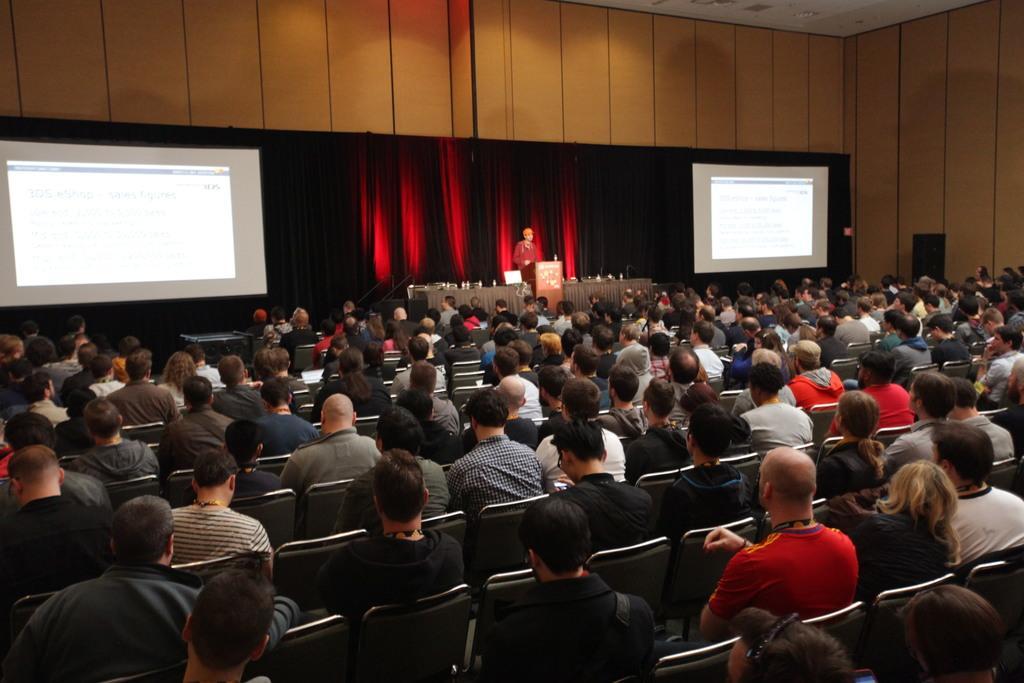Describe this image in one or two sentences. In this image, we can see a group of people. Few are sitting on the chairs. Here a person is standing near the podium. Background we can see curtains, screens and wall. Top of the image, there is a roof. 